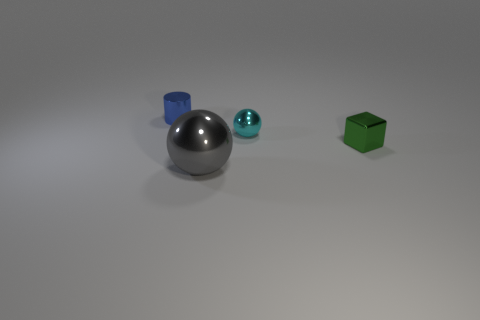Imagine these objects were part of a game, what could the rules involving these shapes be? In a hypothetical game involving these shapes, we could imagine a rule where the goal is to match objects of the same shape and color. Each player might take turns rolling a die with colored faces corresponding to the objects, and each time a player rolls a color, they must find the object that matches the shape and place them together. Points could be awarded for successful matches and deducted for incorrect ones, with special bonuses for matching the rare silver sphere due to its neutral color. 